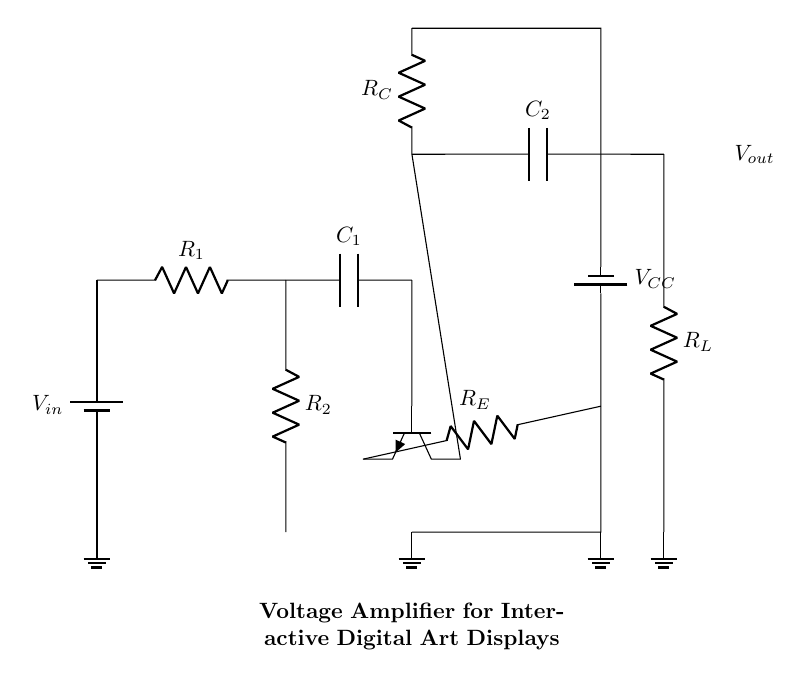What is the input voltage of this circuit? The input voltage is labeled as V_in, which is the voltage provided by the battery in the circuit.
Answer: V_in What type of transistor is used in this amplifier? The transistor in the diagram is an NPN type, which is indicated by the npn notation in the circuit symbol.
Answer: NPN What is the function of capacitor C1? Capacitor C1 is used to couple AC signals while blocking DC, acting as a high-pass filter at the input stage of the amplifier.
Answer: Coupling capacitor What is the resistance value of resistor R_E? The value of R_E is not specified in the circuit, but it is a resistor connected to the emitter of the NPN transistor used for stabilization and biasing.
Answer: Not specified What is the purpose of resistor R_C? Resistor R_C serves in the collector circuit of the transistor, helping to set the gain of the amplifier and stabilize the output voltage.
Answer: Gain setting How is the output voltage labeled in the circuit? The output voltage is indicated with the label V_out in the circuit, connected to the load resistor R_L positioned at the output stage.
Answer: V_out What components are involved in the output stage of the amplifier? The output stage consists of capacitor C2 and load resistor R_L, which facilitate the delivery of the amplified signal to the output.
Answer: C2 and R_L 